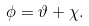Convert formula to latex. <formula><loc_0><loc_0><loc_500><loc_500>\phi = \vartheta + \chi .</formula> 